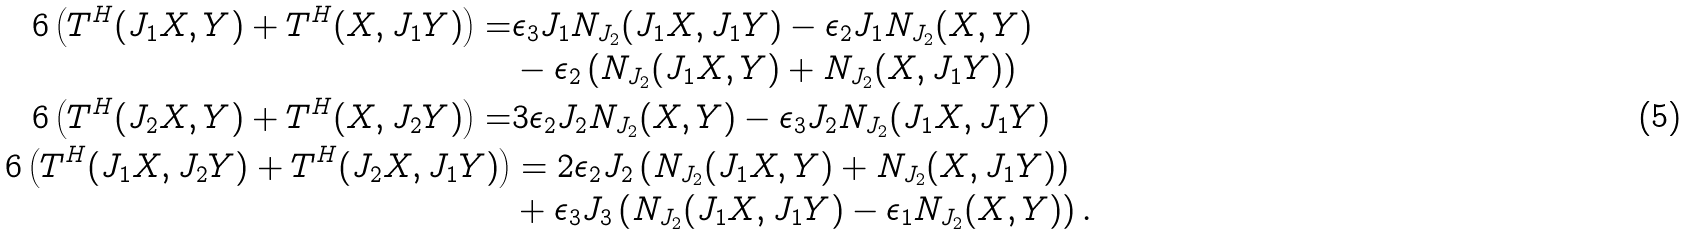Convert formula to latex. <formula><loc_0><loc_0><loc_500><loc_500>6 \left ( T ^ { H } ( J _ { 1 } X , Y ) + T ^ { H } ( X , J _ { 1 } Y ) \right ) = & \epsilon _ { 3 } J _ { 1 } N _ { J _ { 2 } } ( J _ { 1 } X , J _ { 1 } Y ) - \epsilon _ { 2 } J _ { 1 } N _ { J _ { 2 } } ( X , Y ) \\ & - \epsilon _ { 2 } \left ( N _ { J _ { 2 } } ( J _ { 1 } X , Y ) + N _ { J _ { 2 } } ( X , J _ { 1 } Y ) \right ) \\ 6 \left ( T ^ { H } ( J _ { 2 } X , Y ) + T ^ { H } ( X , J _ { 2 } Y ) \right ) = & 3 \epsilon _ { 2 } J _ { 2 } N _ { J _ { 2 } } ( X , Y ) - \epsilon _ { 3 } J _ { 2 } N _ { J _ { 2 } } ( J _ { 1 } X , J _ { 1 } Y ) \\ 6 \left ( T ^ { H } ( J _ { 1 } X , J _ { 2 } Y ) + T ^ { H } ( J _ { 2 } X , J _ { 1 } Y ) \right ) & = 2 \epsilon _ { 2 } J _ { 2 } \left ( N _ { J _ { 2 } } ( J _ { 1 } X , Y ) + N _ { J _ { 2 } } ( X , J _ { 1 } Y ) \right ) \\ & + \epsilon _ { 3 } J _ { 3 } \left ( N _ { J _ { 2 } } ( J _ { 1 } X , J _ { 1 } Y ) - \epsilon _ { 1 } N _ { J _ { 2 } } ( X , Y ) \right ) .</formula> 